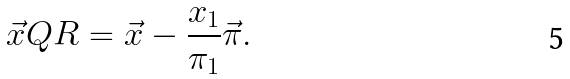<formula> <loc_0><loc_0><loc_500><loc_500>\vec { x } Q R = \vec { x } - \frac { x _ { 1 } } { \pi _ { 1 } } \vec { \pi } .</formula> 